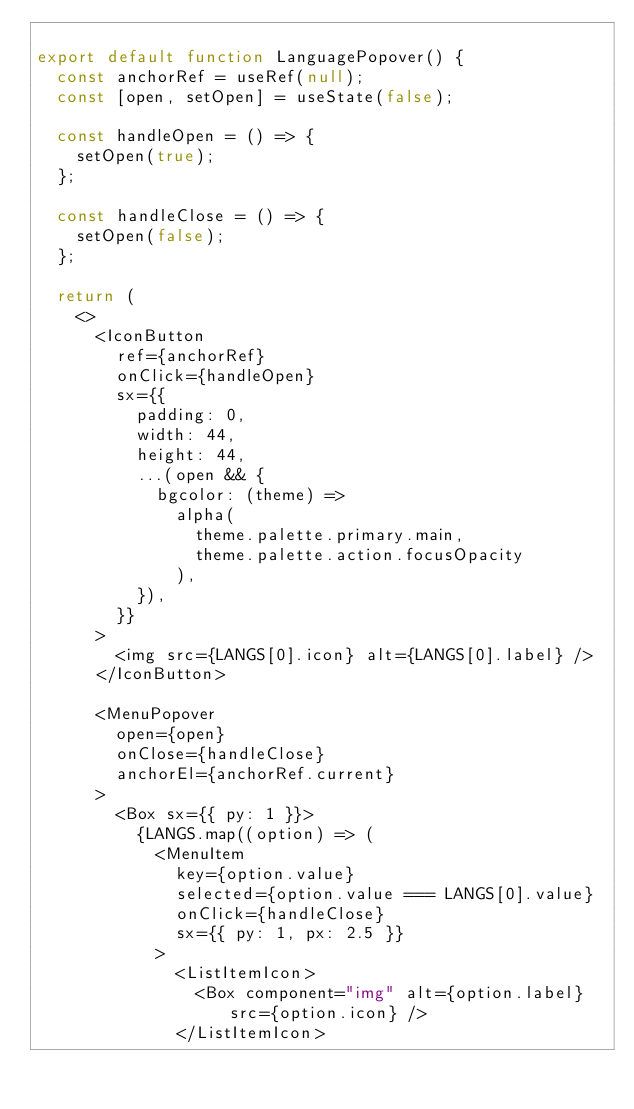<code> <loc_0><loc_0><loc_500><loc_500><_JavaScript_>
export default function LanguagePopover() {
  const anchorRef = useRef(null);
  const [open, setOpen] = useState(false);

  const handleOpen = () => {
    setOpen(true);
  };

  const handleClose = () => {
    setOpen(false);
  };

  return (
    <>
      <IconButton
        ref={anchorRef}
        onClick={handleOpen}
        sx={{
          padding: 0,
          width: 44,
          height: 44,
          ...(open && {
            bgcolor: (theme) =>
              alpha(
                theme.palette.primary.main,
                theme.palette.action.focusOpacity
              ),
          }),
        }}
      >
        <img src={LANGS[0].icon} alt={LANGS[0].label} />
      </IconButton>

      <MenuPopover
        open={open}
        onClose={handleClose}
        anchorEl={anchorRef.current}
      >
        <Box sx={{ py: 1 }}>
          {LANGS.map((option) => (
            <MenuItem
              key={option.value}
              selected={option.value === LANGS[0].value}
              onClick={handleClose}
              sx={{ py: 1, px: 2.5 }}
            >
              <ListItemIcon>
                <Box component="img" alt={option.label} src={option.icon} />
              </ListItemIcon></code> 